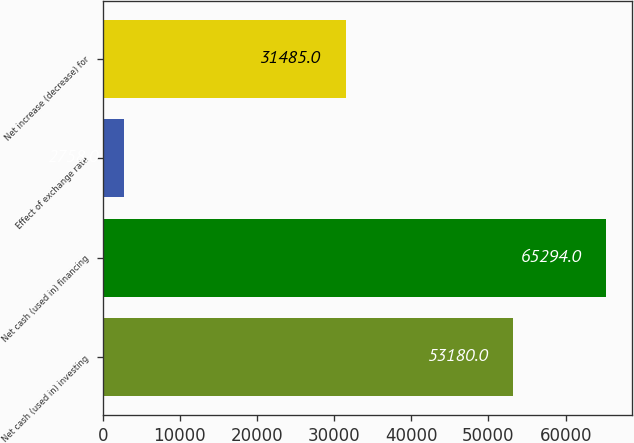Convert chart to OTSL. <chart><loc_0><loc_0><loc_500><loc_500><bar_chart><fcel>Net cash (used in) investing<fcel>Net cash (used in) financing<fcel>Effect of exchange rate<fcel>Net increase (decrease) for<nl><fcel>53180<fcel>65294<fcel>2758<fcel>31485<nl></chart> 